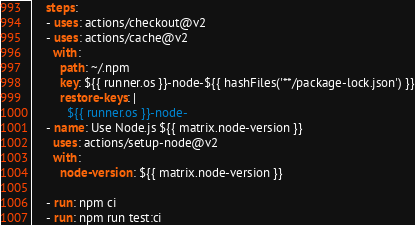Convert code to text. <code><loc_0><loc_0><loc_500><loc_500><_YAML_>
    steps:
    - uses: actions/checkout@v2
    - uses: actions/cache@v2
      with:
        path: ~/.npm
        key: ${{ runner.os }}-node-${{ hashFiles('**/package-lock.json') }}
        restore-keys: |
          ${{ runner.os }}-node-
    - name: Use Node.js ${{ matrix.node-version }}
      uses: actions/setup-node@v2
      with:
        node-version: ${{ matrix.node-version }}

    - run: npm ci
    - run: npm run test:ci
</code> 